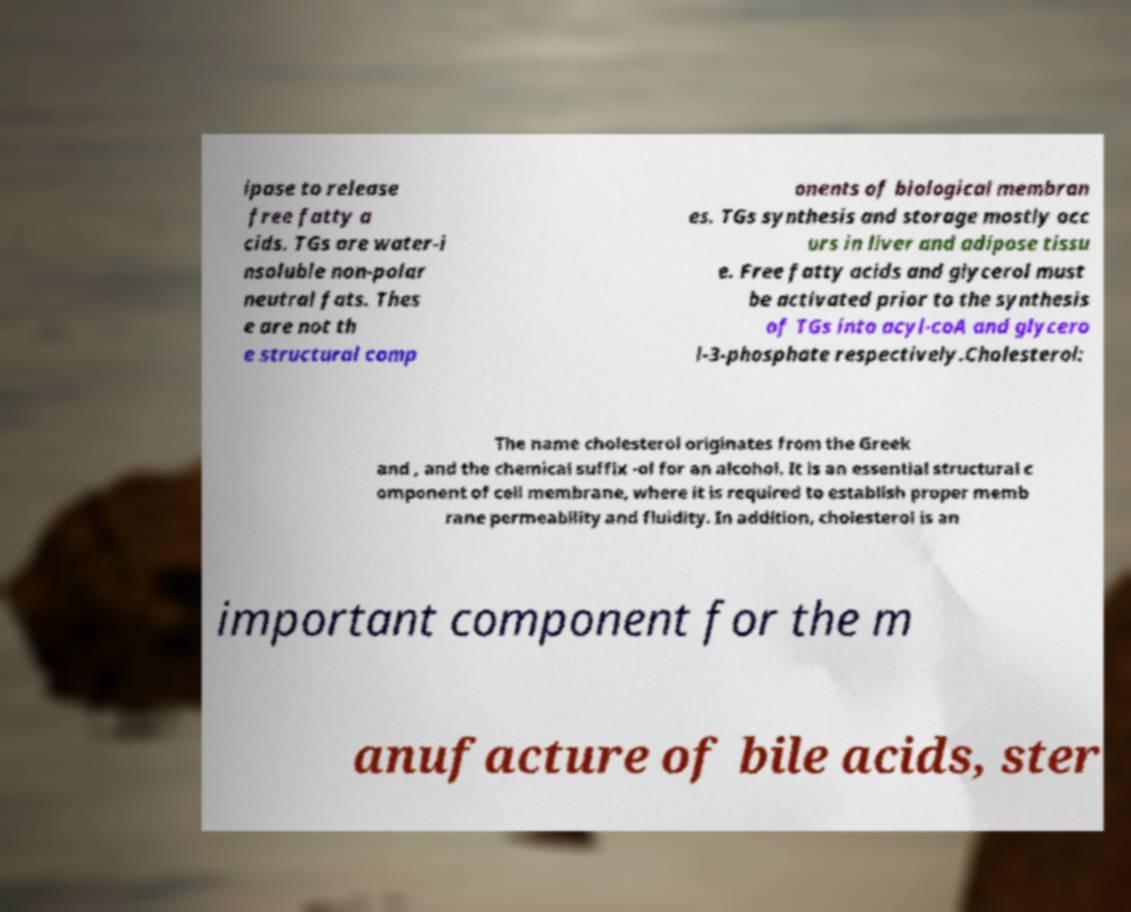I need the written content from this picture converted into text. Can you do that? ipase to release free fatty a cids. TGs are water-i nsoluble non-polar neutral fats. Thes e are not th e structural comp onents of biological membran es. TGs synthesis and storage mostly occ urs in liver and adipose tissu e. Free fatty acids and glycerol must be activated prior to the synthesis of TGs into acyl-coA and glycero l-3-phosphate respectively.Cholesterol: The name cholesterol originates from the Greek and , and the chemical suffix -ol for an alcohol. It is an essential structural c omponent of cell membrane, where it is required to establish proper memb rane permeability and fluidity. In addition, cholesterol is an important component for the m anufacture of bile acids, ster 